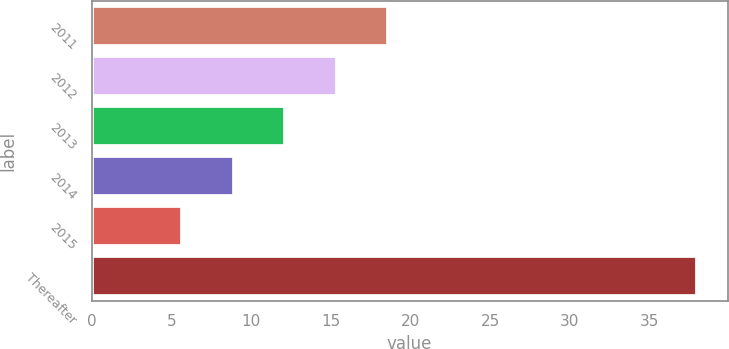Convert chart to OTSL. <chart><loc_0><loc_0><loc_500><loc_500><bar_chart><fcel>2011<fcel>2012<fcel>2013<fcel>2014<fcel>2015<fcel>Thereafter<nl><fcel>18.62<fcel>15.39<fcel>12.16<fcel>8.93<fcel>5.7<fcel>38<nl></chart> 